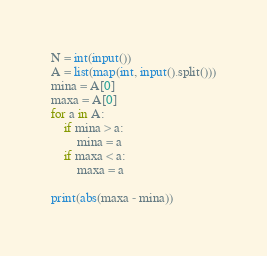Convert code to text. <code><loc_0><loc_0><loc_500><loc_500><_Python_>N = int(input())
A = list(map(int, input().split()))
mina = A[0]
maxa = A[0]
for a in A:
    if mina > a:
        mina = a
    if maxa < a:
        maxa = a

print(abs(maxa - mina))
</code> 